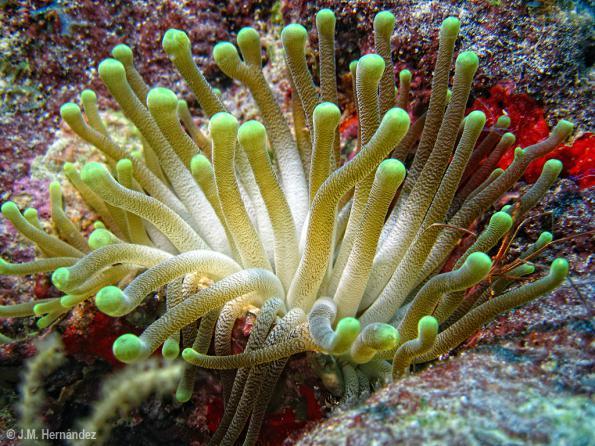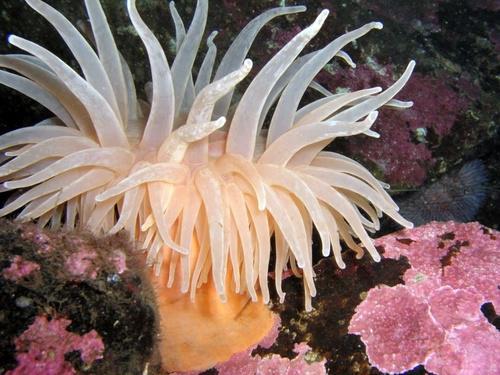The first image is the image on the left, the second image is the image on the right. Analyze the images presented: Is the assertion "The lefthand image contains an anemone with pink bits, the righthand image contains a mostly white anemone." valid? Answer yes or no. No. The first image is the image on the left, the second image is the image on the right. For the images displayed, is the sentence "At least one anemone is red or green and another is white." factually correct? Answer yes or no. No. 